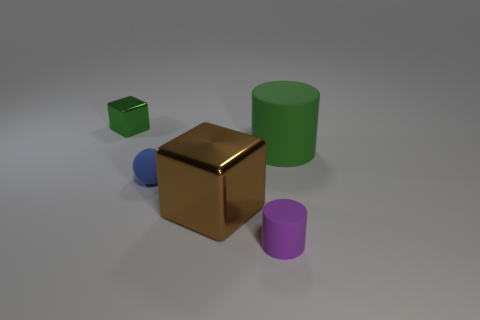There is a small thing that is in front of the tiny green cube and left of the purple thing; what color is it?
Give a very brief answer. Blue. What number of tiny metal blocks are there?
Offer a very short reply. 1. Do the green shiny cube and the blue rubber ball have the same size?
Your answer should be compact. Yes. Is there a tiny rubber sphere that has the same color as the tiny block?
Ensure brevity in your answer.  No. There is a big thing that is to the right of the big metal block; is it the same shape as the small green metallic thing?
Provide a short and direct response. No. What number of green rubber objects are the same size as the brown shiny object?
Offer a terse response. 1. What number of tiny metal objects are behind the shiny block in front of the small shiny object?
Provide a short and direct response. 1. Are the block in front of the blue rubber thing and the blue object made of the same material?
Offer a terse response. No. Does the thing on the right side of the purple object have the same material as the large thing on the left side of the tiny rubber cylinder?
Your response must be concise. No. Is the number of blue spheres that are right of the purple object greater than the number of large purple rubber objects?
Your answer should be very brief. No. 